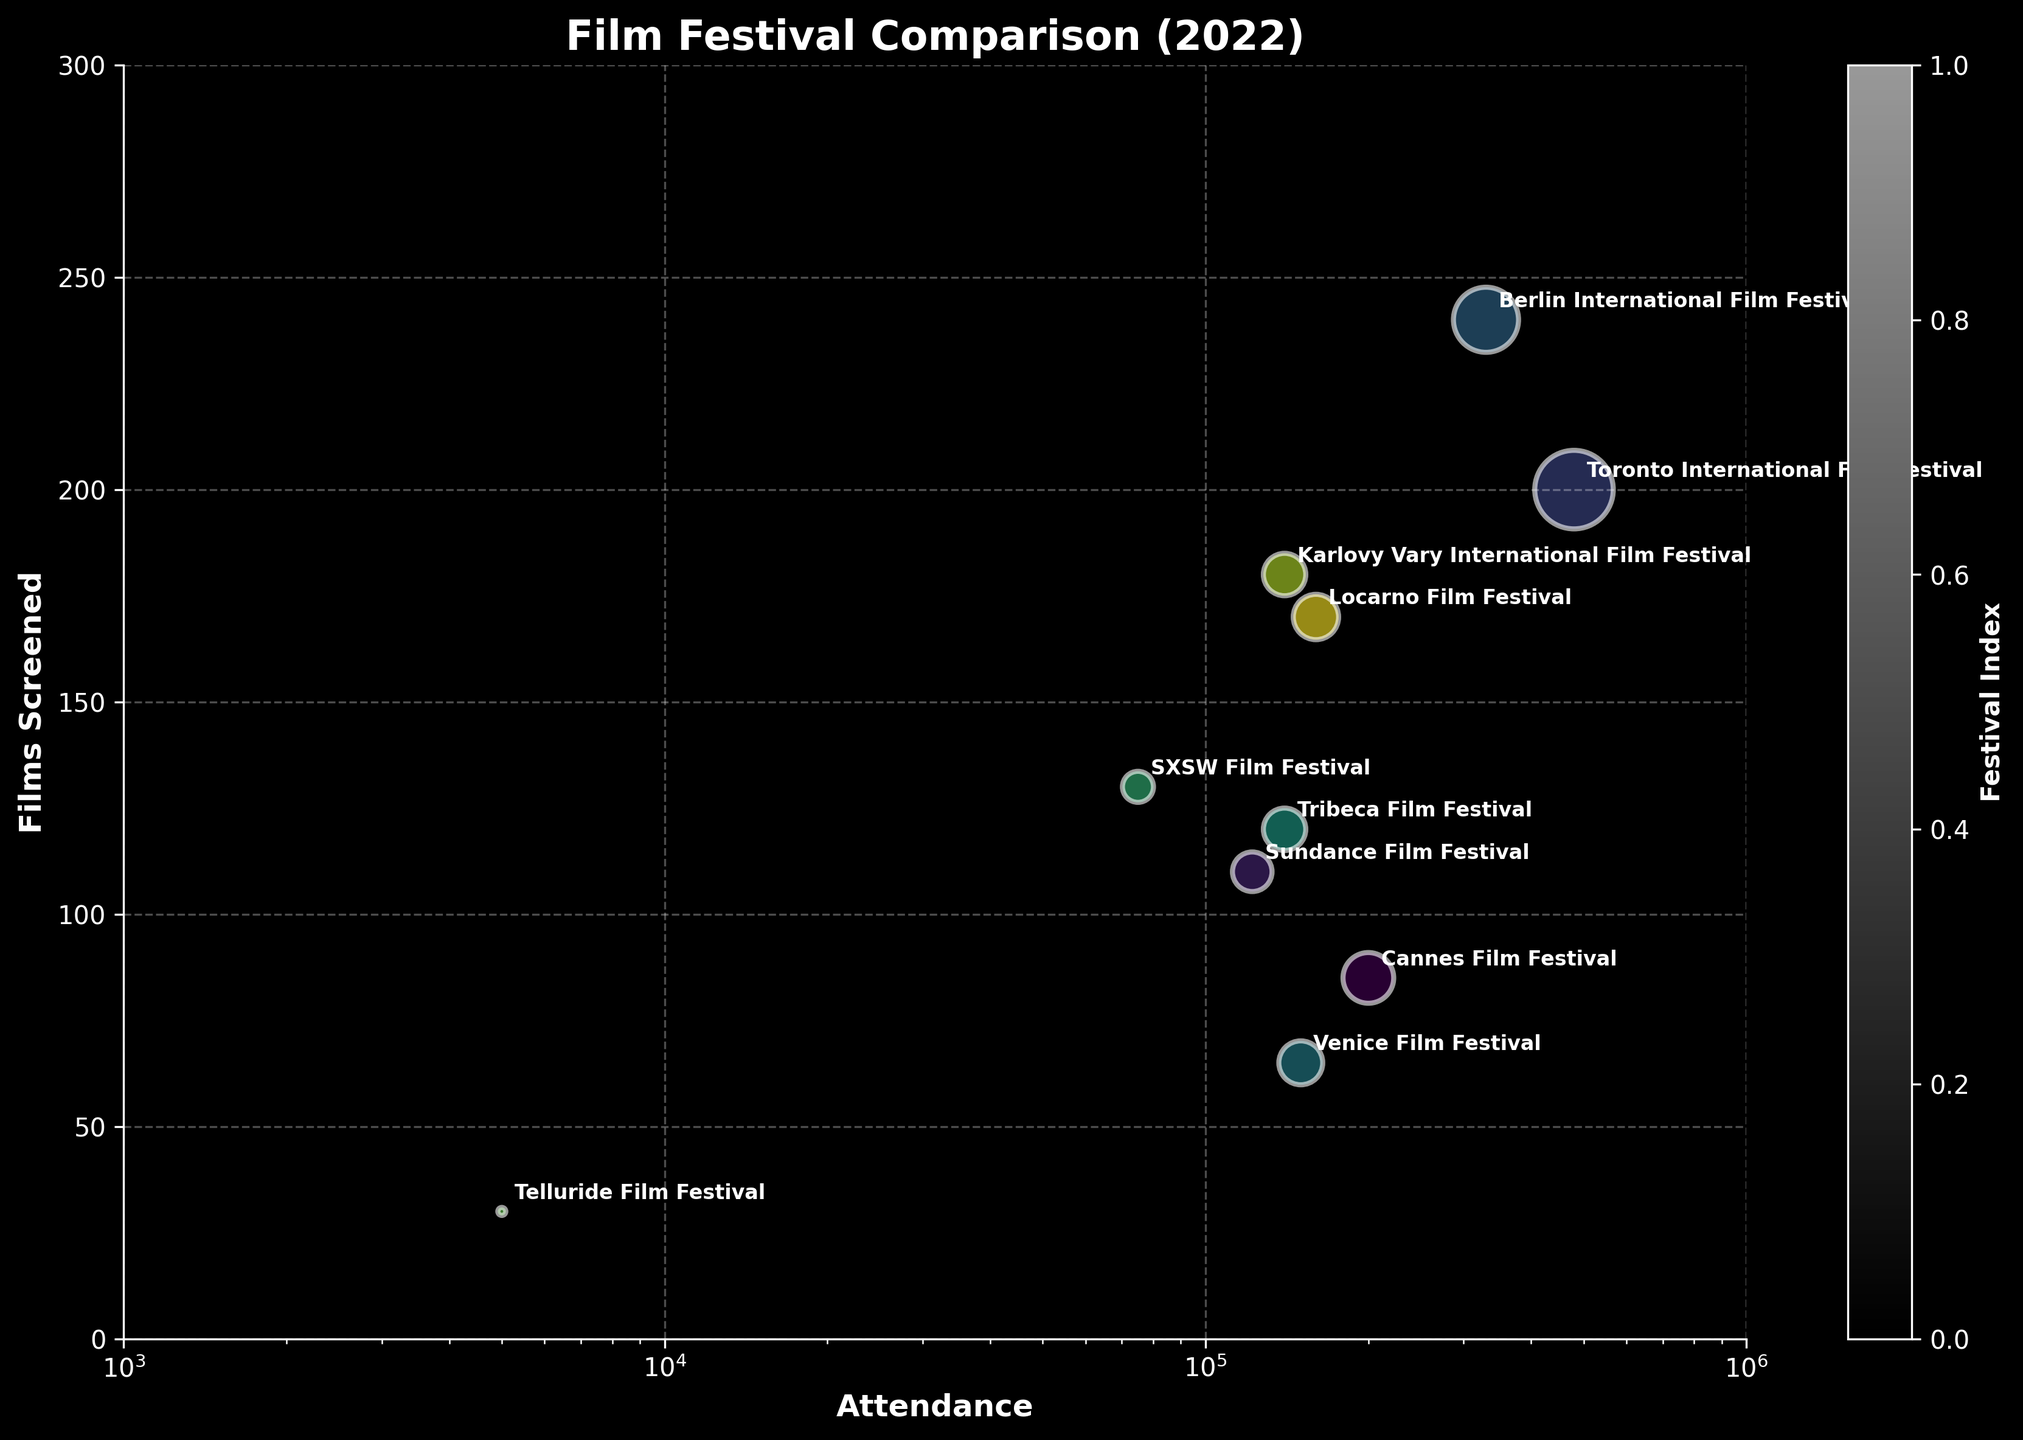What's the title of the figure? The title is located at the top of the figure and provides an overview of what the figure represents. It reads 'Film Festival Comparison (2022)'.
Answer: 'Film Festival Comparison (2022)' Which festival has the highest attendance? By looking at the horizontal axis (Attendance), the Toronto International Film Festival is the furthest to the right, indicating the highest attendance.
Answer: Toronto International Film Festival How does the attendance of the Telluride Film Festival compare to other festivals? The Telluride Film Festival is positioned far to the left on the axis (Attendance), indicating much lower attendance compared to other festivals.
Answer: It has significantly lower attendance Which festival screened the most films? On the vertical axis (Films Screened), the Berlin International Film Festival is the highest, indicating it screened the most films.
Answer: Berlin International Film Festival Compare the number of films screened between the Cannes Film Festival and SXSW Film Festival. By observing their positions on the vertical axis, the Cannes Film Festival is lower than the SXSW Film Festival, indicating it screened fewer films.
Answer: Cannes Film Festival screened fewer films How does the bubble size for the Locarno Film Festival compare to that of the Venice Film Festival? Bubble size indicates the number of films screened, so checking their sizes visually, the Locarno Film Festival's bubble is similar or slightly larger than that of the Venice Film Festival, corresponding to more films screened.
Answer: Locarno Film Festival's bubble is slightly larger What's the relationship between attendance and films screened in these festivals? Observing the overall distribution, there's no clear linear relationship; some festivals with high attendance have fewer films, and some with lower attendance have many films screened.
Answer: No clear linear relationship Which festival has the smallest bubble size, indicating the least number of films screened? By visual comparison of bubble sizes, the Telluride Film Festival has the smallest bubble, indicating it screened the fewest films.
Answer: Telluride Film Festival Is the Toronto International Film Festival the one with the highest attendance and also the most films screened? While the Toronto International Film Festival has the highest attendance (rightmost position), it does not have the most films screened (not the highest bubble). That rank goes to the Berlin International Film Festival.
Answer: No If you combined the films screened at Cannes and Venice Film Festivals, how many films would that be? Cannes Film Festival screened 85 films, and Venice Film Festival screened 65. Adding them gives 85 + 65 = 150.
Answer: 150 